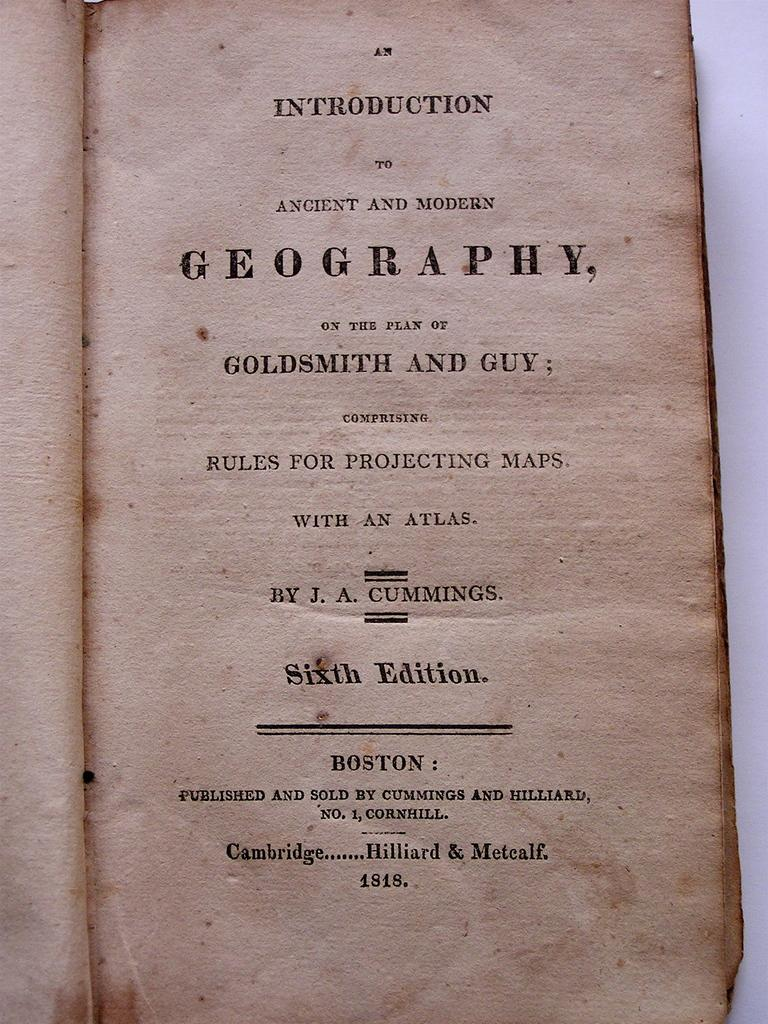<image>
Provide a brief description of the given image. An old geography book with maps and an atlas is open to the main page on the table. 